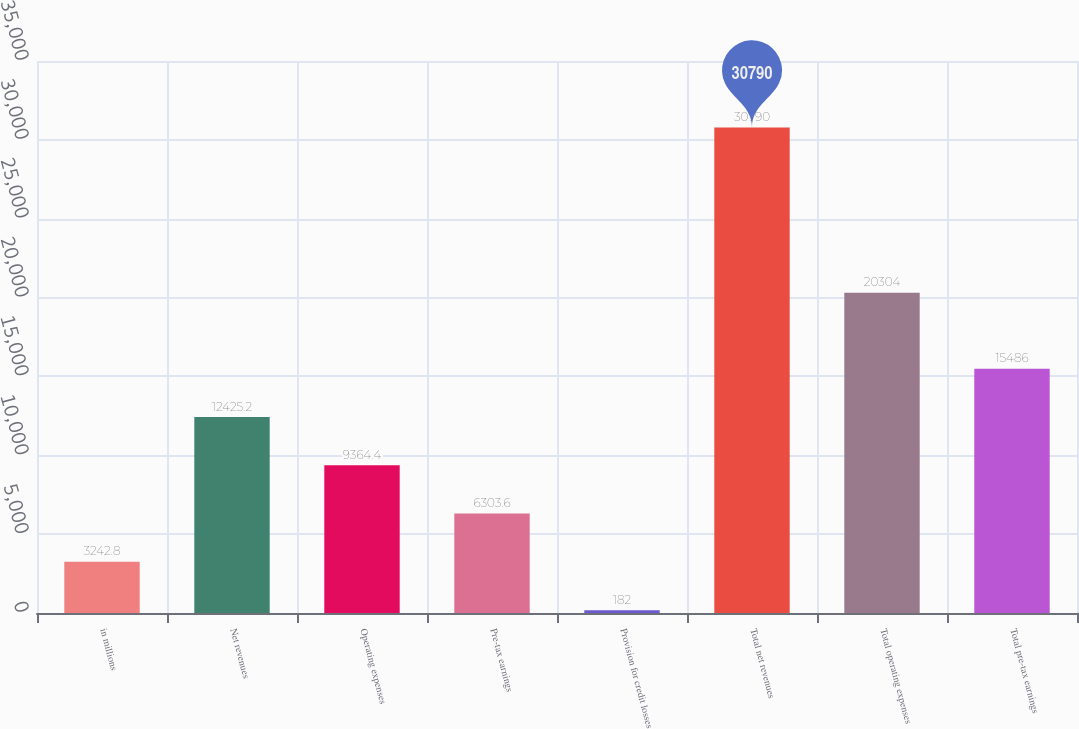Convert chart to OTSL. <chart><loc_0><loc_0><loc_500><loc_500><bar_chart><fcel>in millions<fcel>Net revenues<fcel>Operating expenses<fcel>Pre-tax earnings<fcel>Provision for credit losses<fcel>Total net revenues<fcel>Total operating expenses<fcel>Total pre-tax earnings<nl><fcel>3242.8<fcel>12425.2<fcel>9364.4<fcel>6303.6<fcel>182<fcel>30790<fcel>20304<fcel>15486<nl></chart> 